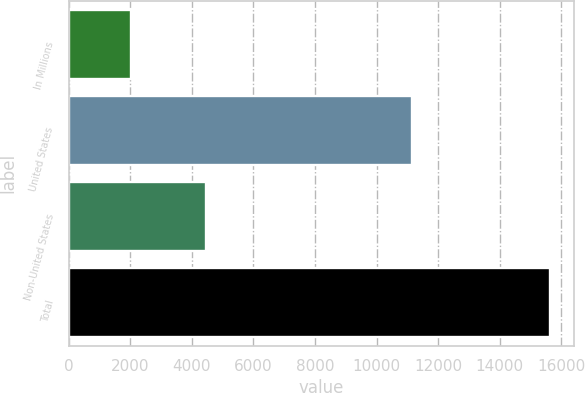Convert chart to OTSL. <chart><loc_0><loc_0><loc_500><loc_500><bar_chart><fcel>In Millions<fcel>United States<fcel>Non-United States<fcel>Total<nl><fcel>2017<fcel>11160.9<fcel>4458.9<fcel>15619.8<nl></chart> 